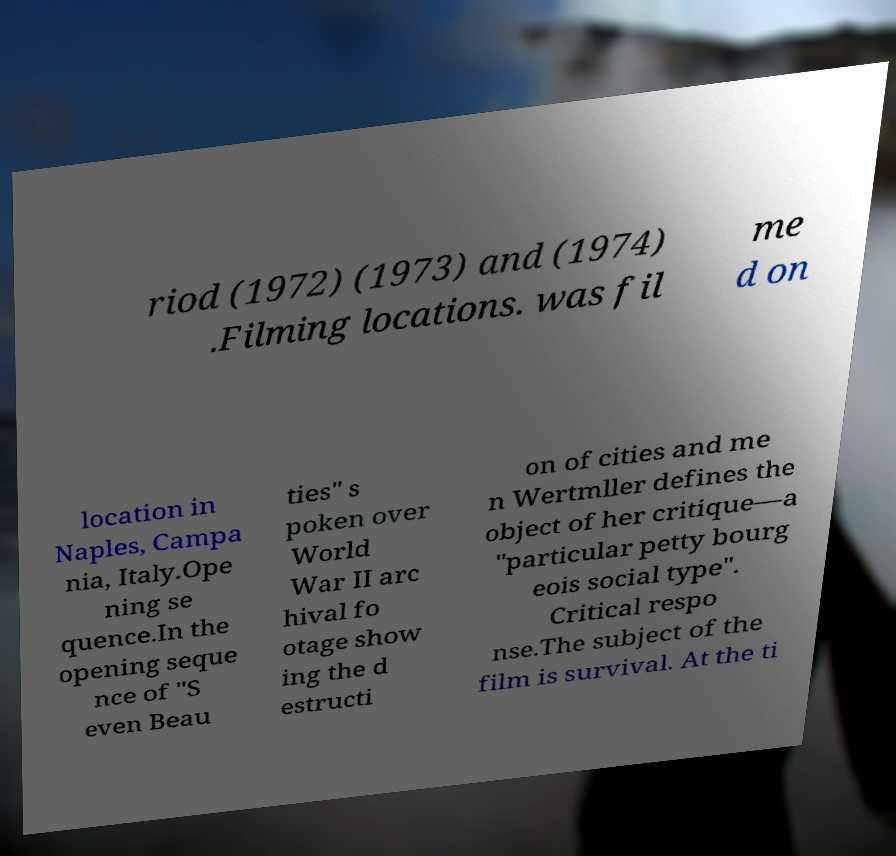Could you extract and type out the text from this image? riod (1972) (1973) and (1974) .Filming locations. was fil me d on location in Naples, Campa nia, Italy.Ope ning se quence.In the opening seque nce of "S even Beau ties" s poken over World War II arc hival fo otage show ing the d estructi on of cities and me n Wertmller defines the object of her critique—a "particular petty bourg eois social type". Critical respo nse.The subject of the film is survival. At the ti 